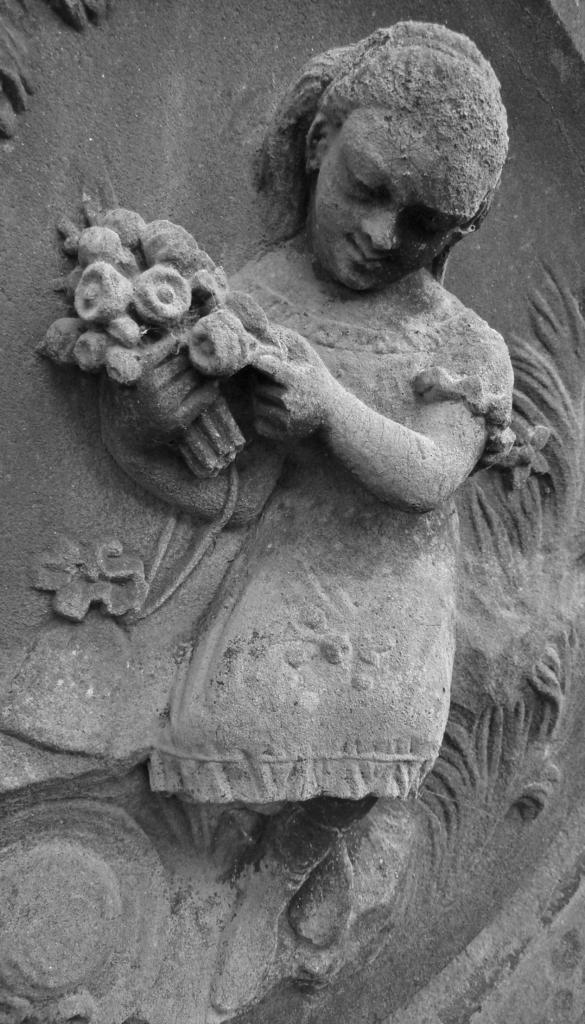What is the main subject of the image? There is a carving of a girl in the image. What else can be seen in the image besides the carving? There are plants in the image. What type of wool is the cow wearing in the image? There is no cow or wool present in the image; it features a carving of a girl and plants. 